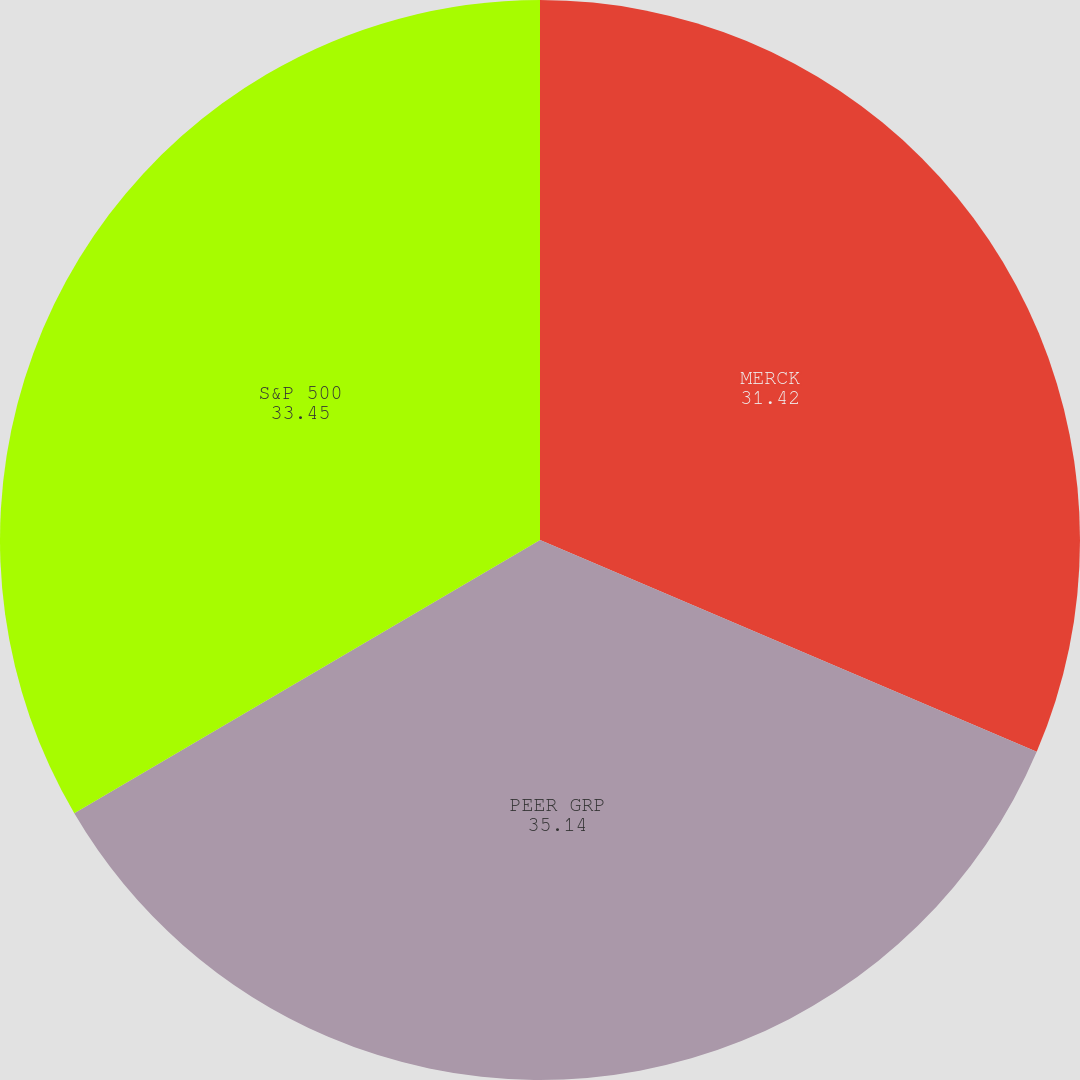Convert chart to OTSL. <chart><loc_0><loc_0><loc_500><loc_500><pie_chart><fcel>MERCK<fcel>PEER GRP<fcel>S&P 500<nl><fcel>31.42%<fcel>35.14%<fcel>33.45%<nl></chart> 